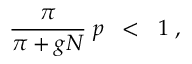<formula> <loc_0><loc_0><loc_500><loc_500>\frac { \pi } { \pi + g N } \, p \, < \, 1 \, ,</formula> 